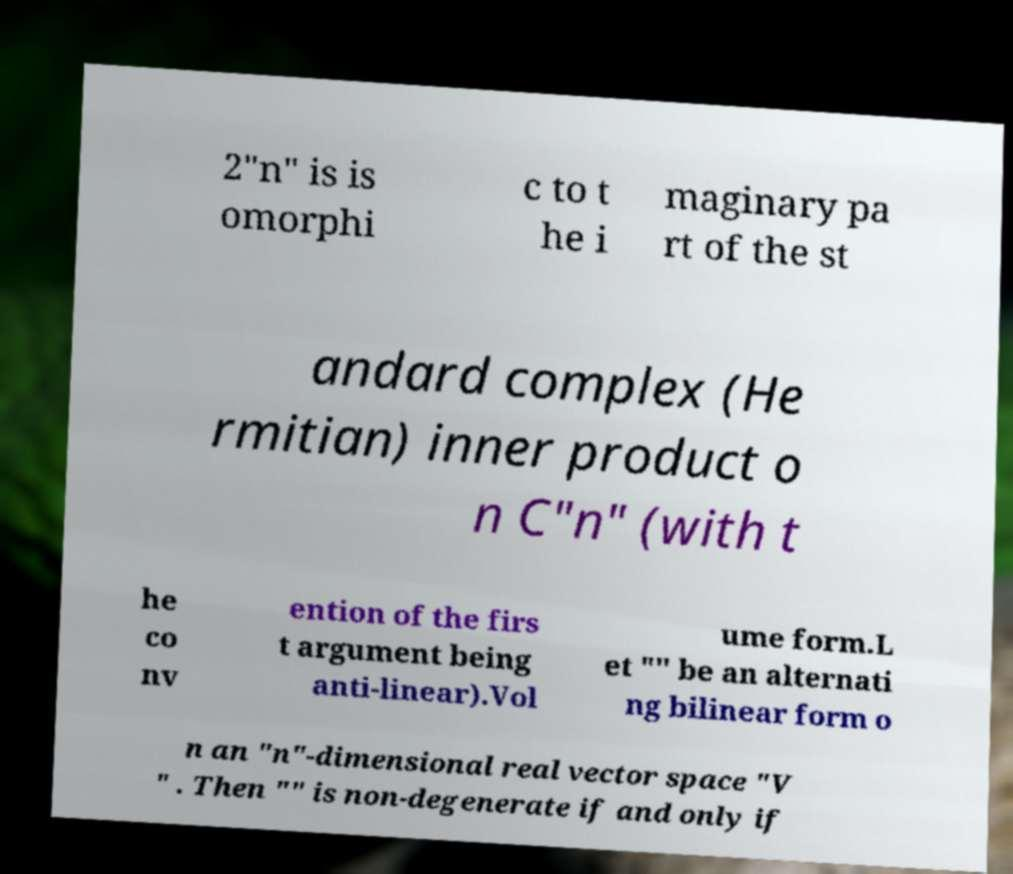Can you accurately transcribe the text from the provided image for me? 2"n" is is omorphi c to t he i maginary pa rt of the st andard complex (He rmitian) inner product o n C"n" (with t he co nv ention of the firs t argument being anti-linear).Vol ume form.L et "" be an alternati ng bilinear form o n an "n"-dimensional real vector space "V " . Then "" is non-degenerate if and only if 